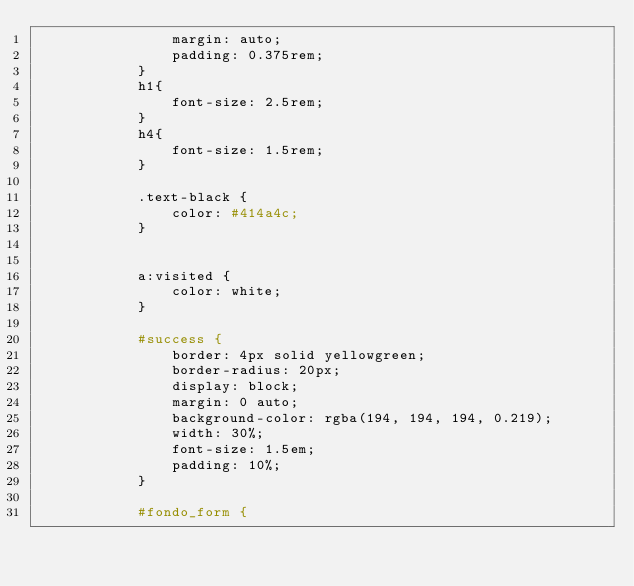<code> <loc_0><loc_0><loc_500><loc_500><_PHP_>                margin: auto;
                padding: 0.375rem;
            }
            h1{
                font-size: 2.5rem;
            }
            h4{
                font-size: 1.5rem;
            }

            .text-black {
                color: #414a4c;
            }

           
            a:visited {
                color: white;
            }

            #success {
                border: 4px solid yellowgreen;
                border-radius: 20px;
                display: block;
                margin: 0 auto;
                background-color: rgba(194, 194, 194, 0.219);
                width: 30%;
                font-size: 1.5em;
                padding: 10%;
            }

            #fondo_form {</code> 